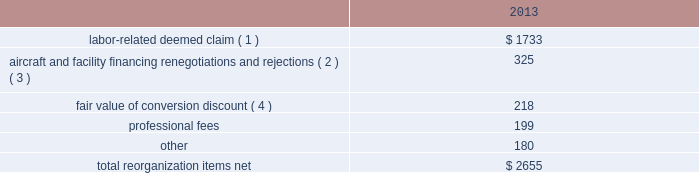Table of contents the following discussion of nonoperating income and expense excludes the results of the merger in order to provide a more meaningful year-over-year comparison .
Interest expense , net of capitalized interest decreased $ 249 million in 2014 from 2013 primarily due to a $ 149 million decrease in special charges recognized year-over-year as further described below , as well as refinancing activities that resulted in $ 100 million less interest expense recognized in 2014 .
( 1 ) in 2014 , we recognized $ 33 million of special charges relating to non-cash interest accretion on bankruptcy settlement obligations .
In 2013 , we recognized $ 138 million of special charges relating to post-petition interest expense on unsecured obligations pursuant to the plan and penalty interest related to american 2019s 10.5% ( 10.5 % ) secured notes and 7.50% ( 7.50 % ) senior secured notes .
In addition , in 2013 we recorded special charges of $ 44 million for debt extinguishment costs incurred as a result of the repayment of certain aircraft secured indebtedness , including cash interest charges and non-cash write offs of unamortized debt issuance costs .
( 2 ) as a result of the 2013 refinancing activities and the early extinguishment of american 2019s 7.50% ( 7.50 % ) senior secured notes in 2014 , we recognized $ 100 million less interest expense in 2014 as compared to 2013 .
Other nonoperating expense , net in 2014 consisted of $ 114 million of net foreign currency losses , including a $ 43 million special charge for venezuelan foreign currency losses , and $ 56 million in other nonoperating special charges primarily due to early debt extinguishment costs related to the prepayment of our 7.50% ( 7.50 % ) senior secured notes and other indebtedness .
The foreign currency losses were driven primarily by the strengthening of the u.s .
Dollar relative to other currencies during 2014 , principally in the latin american market , including a 48% ( 48 % ) decrease in the value of the venezuelan bolivar and a 14% ( 14 % ) decrease in the value of the brazilian real .
Other nonoperating expense , net in 2013 consisted principally of net foreign currency losses of $ 56 million and early debt extinguishment charges of $ 29 million .
Reorganization items , net reorganization items refer to revenues , expenses ( including professional fees ) , realized gains and losses and provisions for losses that are realized or incurred as a direct result of the chapter 11 cases .
The table summarizes the components included in reorganization items , net on aag 2019s consolidated statement of operations for the year ended december 31 , 2013 ( in millions ) : .
( 1 ) in exchange for employees 2019 contributions to the successful reorganization , including agreeing to reductions in pay and benefits , we agreed in the plan to provide each employee group a deemed claim , which was used to provide a distribution of a portion of the equity of the reorganized entity to those employees .
Each employee group received a deemed claim amount based upon a portion of the value of cost savings provided by that group through reductions to pay and benefits as well as through certain work rule changes .
The total value of this deemed claim was approximately $ 1.7 billion .
( 2 ) amounts include allowed claims ( claims approved by the bankruptcy court ) and estimated allowed claims relating to ( i ) the rejection or modification of financings related to aircraft and ( ii ) entry of orders treated as unsecured claims with respect to facility agreements supporting certain issuances of special facility revenue bonds .
The debtors recorded an estimated claim associated with the rejection or modification of a financing .
What was the percentage change in the net foreign currency losses , net in 2014 compared to 2013? 
Computations: ((114 - 56) / 56)
Answer: 1.03571. 